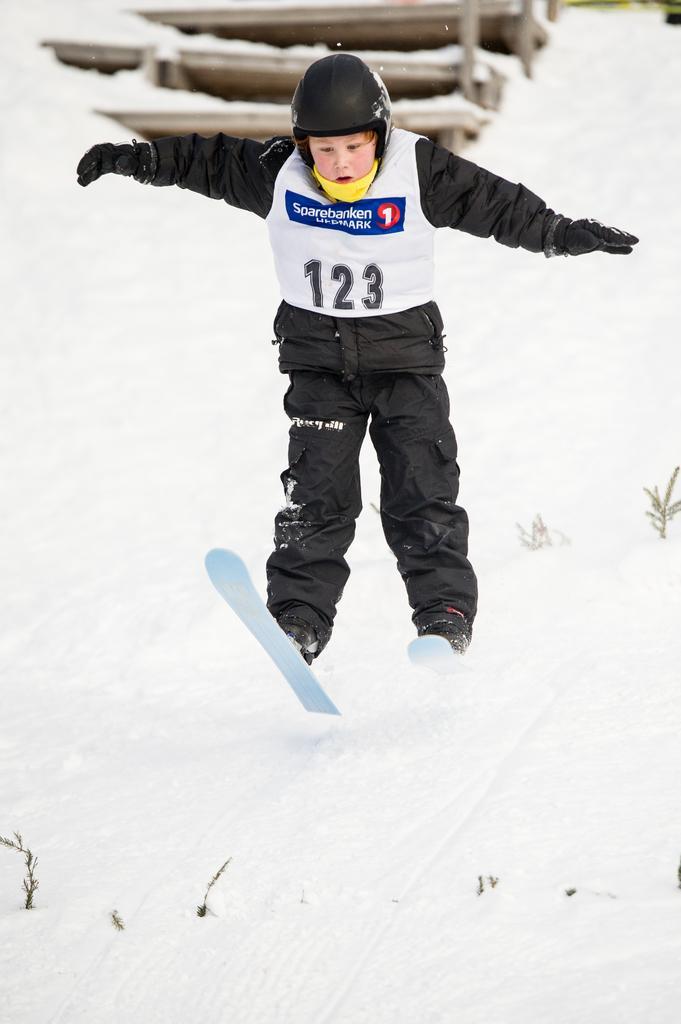In one or two sentences, can you explain what this image depicts? In this image i can see a boy on the snow at the background i can see a wooden stairs. 